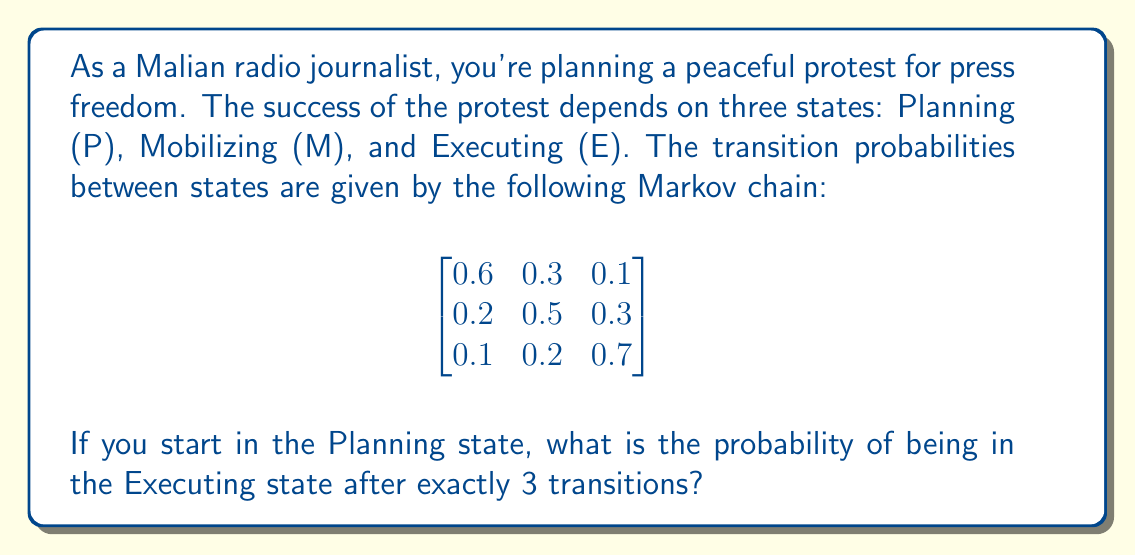Can you answer this question? To solve this problem, we'll use the Markov chain transition matrix and calculate its third power. Let's approach this step-by-step:

1) The given transition matrix is:

   $$P = \begin{bmatrix}
   0.6 & 0.3 & 0.1 \\
   0.2 & 0.5 & 0.3 \\
   0.1 & 0.2 & 0.7
   \end{bmatrix}$$

2) We need to calculate $P^3$, which represents the probability of transitioning between states after exactly 3 steps.

3) Let's calculate $P^2$ first:

   $$P^2 = \begin{bmatrix}
   0.42 & 0.33 & 0.25 \\
   0.29 & 0.40 & 0.31 \\
   0.22 & 0.29 & 0.49
   \end{bmatrix}$$

4) Now, we can calculate $P^3 = P \times P^2$:

   $$P^3 = \begin{bmatrix}
   0.356 & 0.339 & 0.305 \\
   0.308 & 0.352 & 0.340 \\
   0.263 & 0.308 & 0.429
   \end{bmatrix}$$

5) The probability of starting in the Planning state (P) and ending in the Executing state (E) after 3 transitions is given by the element in the first row, third column of $P^3$.

Therefore, the probability is 0.305 or 30.5%.
Answer: 0.305 